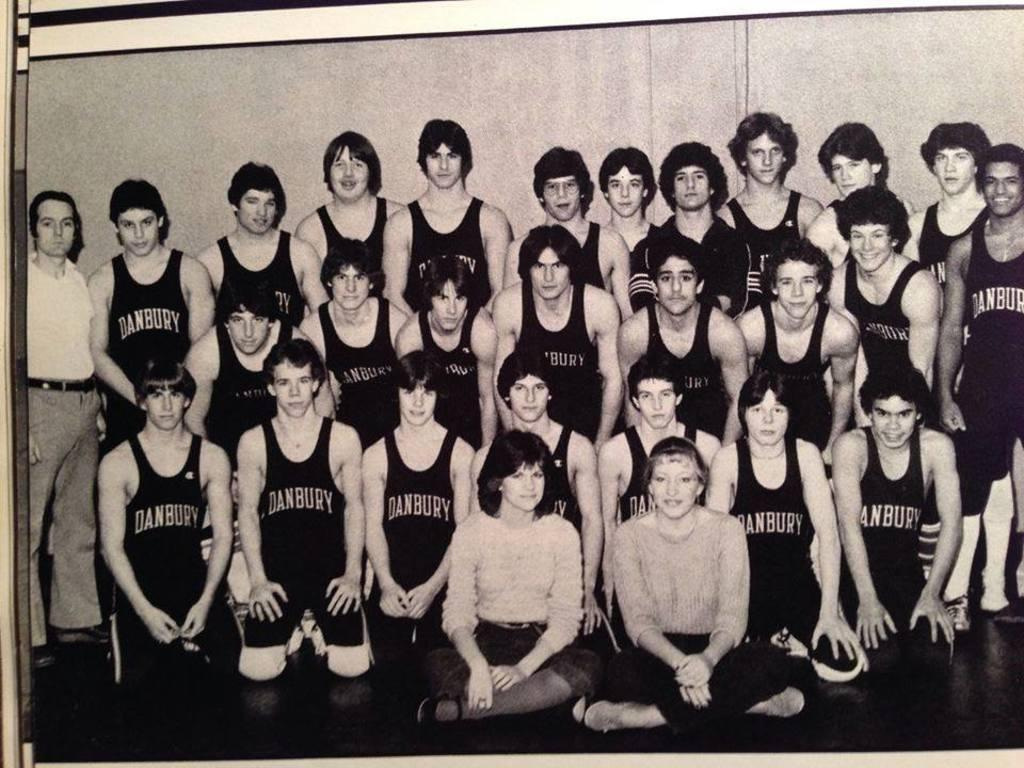Provide a one-sentence caption for the provided image. A black and white photo of Danbury wrestlers posed for a group picture. 